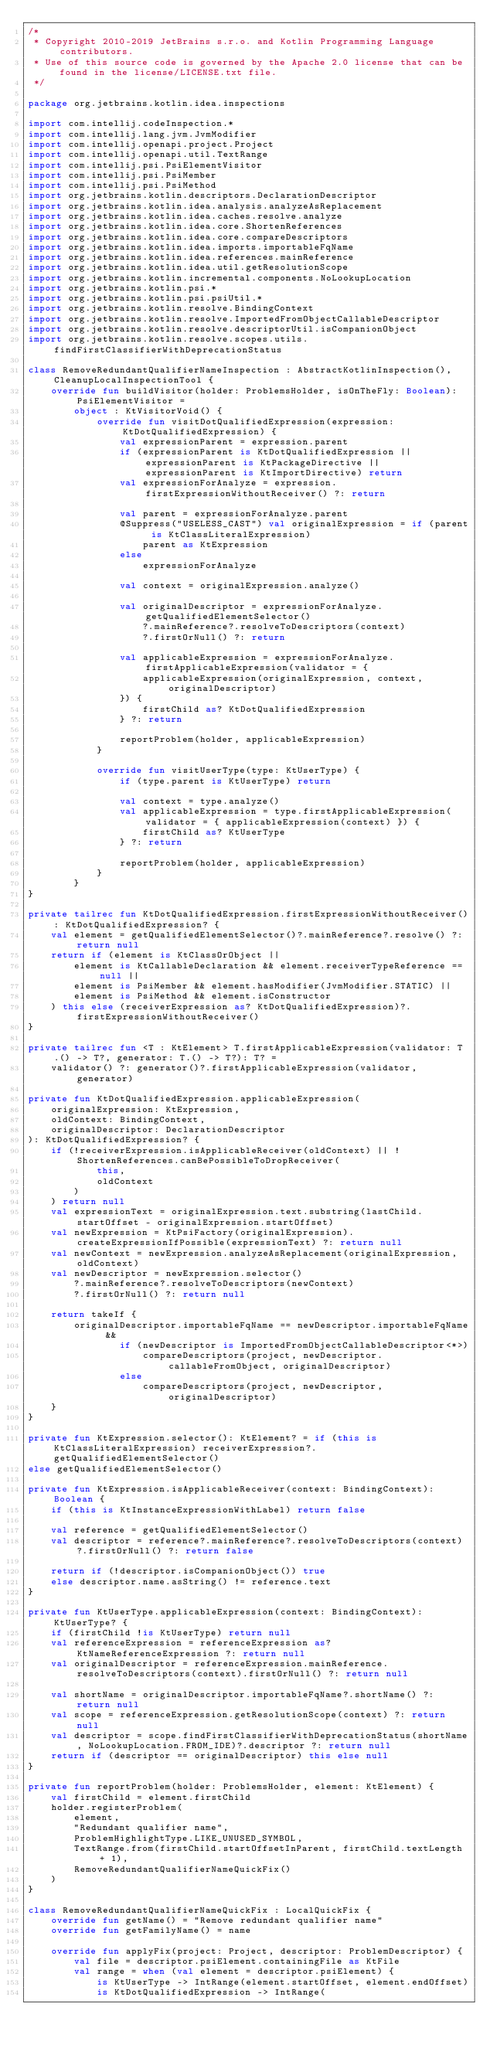Convert code to text. <code><loc_0><loc_0><loc_500><loc_500><_Kotlin_>/*
 * Copyright 2010-2019 JetBrains s.r.o. and Kotlin Programming Language contributors.
 * Use of this source code is governed by the Apache 2.0 license that can be found in the license/LICENSE.txt file.
 */

package org.jetbrains.kotlin.idea.inspections

import com.intellij.codeInspection.*
import com.intellij.lang.jvm.JvmModifier
import com.intellij.openapi.project.Project
import com.intellij.openapi.util.TextRange
import com.intellij.psi.PsiElementVisitor
import com.intellij.psi.PsiMember
import com.intellij.psi.PsiMethod
import org.jetbrains.kotlin.descriptors.DeclarationDescriptor
import org.jetbrains.kotlin.idea.analysis.analyzeAsReplacement
import org.jetbrains.kotlin.idea.caches.resolve.analyze
import org.jetbrains.kotlin.idea.core.ShortenReferences
import org.jetbrains.kotlin.idea.core.compareDescriptors
import org.jetbrains.kotlin.idea.imports.importableFqName
import org.jetbrains.kotlin.idea.references.mainReference
import org.jetbrains.kotlin.idea.util.getResolutionScope
import org.jetbrains.kotlin.incremental.components.NoLookupLocation
import org.jetbrains.kotlin.psi.*
import org.jetbrains.kotlin.psi.psiUtil.*
import org.jetbrains.kotlin.resolve.BindingContext
import org.jetbrains.kotlin.resolve.ImportedFromObjectCallableDescriptor
import org.jetbrains.kotlin.resolve.descriptorUtil.isCompanionObject
import org.jetbrains.kotlin.resolve.scopes.utils.findFirstClassifierWithDeprecationStatus

class RemoveRedundantQualifierNameInspection : AbstractKotlinInspection(), CleanupLocalInspectionTool {
    override fun buildVisitor(holder: ProblemsHolder, isOnTheFly: Boolean): PsiElementVisitor =
        object : KtVisitorVoid() {
            override fun visitDotQualifiedExpression(expression: KtDotQualifiedExpression) {
                val expressionParent = expression.parent
                if (expressionParent is KtDotQualifiedExpression || expressionParent is KtPackageDirective || expressionParent is KtImportDirective) return
                val expressionForAnalyze = expression.firstExpressionWithoutReceiver() ?: return

                val parent = expressionForAnalyze.parent
                @Suppress("USELESS_CAST") val originalExpression = if (parent is KtClassLiteralExpression)
                    parent as KtExpression
                else
                    expressionForAnalyze

                val context = originalExpression.analyze()

                val originalDescriptor = expressionForAnalyze.getQualifiedElementSelector()
                    ?.mainReference?.resolveToDescriptors(context)
                    ?.firstOrNull() ?: return

                val applicableExpression = expressionForAnalyze.firstApplicableExpression(validator = {
                    applicableExpression(originalExpression, context, originalDescriptor)
                }) {
                    firstChild as? KtDotQualifiedExpression
                } ?: return

                reportProblem(holder, applicableExpression)
            }

            override fun visitUserType(type: KtUserType) {
                if (type.parent is KtUserType) return

                val context = type.analyze()
                val applicableExpression = type.firstApplicableExpression(validator = { applicableExpression(context) }) {
                    firstChild as? KtUserType
                } ?: return

                reportProblem(holder, applicableExpression)
            }
        }
}

private tailrec fun KtDotQualifiedExpression.firstExpressionWithoutReceiver(): KtDotQualifiedExpression? {
    val element = getQualifiedElementSelector()?.mainReference?.resolve() ?: return null
    return if (element is KtClassOrObject ||
        element is KtCallableDeclaration && element.receiverTypeReference == null ||
        element is PsiMember && element.hasModifier(JvmModifier.STATIC) ||
        element is PsiMethod && element.isConstructor
    ) this else (receiverExpression as? KtDotQualifiedExpression)?.firstExpressionWithoutReceiver()
}

private tailrec fun <T : KtElement> T.firstApplicableExpression(validator: T.() -> T?, generator: T.() -> T?): T? =
    validator() ?: generator()?.firstApplicableExpression(validator, generator)

private fun KtDotQualifiedExpression.applicableExpression(
    originalExpression: KtExpression,
    oldContext: BindingContext,
    originalDescriptor: DeclarationDescriptor
): KtDotQualifiedExpression? {
    if (!receiverExpression.isApplicableReceiver(oldContext) || !ShortenReferences.canBePossibleToDropReceiver(
            this,
            oldContext
        )
    ) return null
    val expressionText = originalExpression.text.substring(lastChild.startOffset - originalExpression.startOffset)
    val newExpression = KtPsiFactory(originalExpression).createExpressionIfPossible(expressionText) ?: return null
    val newContext = newExpression.analyzeAsReplacement(originalExpression, oldContext)
    val newDescriptor = newExpression.selector()
        ?.mainReference?.resolveToDescriptors(newContext)
        ?.firstOrNull() ?: return null

    return takeIf {
        originalDescriptor.importableFqName == newDescriptor.importableFqName &&
                if (newDescriptor is ImportedFromObjectCallableDescriptor<*>)
                    compareDescriptors(project, newDescriptor.callableFromObject, originalDescriptor)
                else
                    compareDescriptors(project, newDescriptor, originalDescriptor)
    }
}

private fun KtExpression.selector(): KtElement? = if (this is KtClassLiteralExpression) receiverExpression?.getQualifiedElementSelector()
else getQualifiedElementSelector()

private fun KtExpression.isApplicableReceiver(context: BindingContext): Boolean {
    if (this is KtInstanceExpressionWithLabel) return false

    val reference = getQualifiedElementSelector()
    val descriptor = reference?.mainReference?.resolveToDescriptors(context)?.firstOrNull() ?: return false

    return if (!descriptor.isCompanionObject()) true
    else descriptor.name.asString() != reference.text
}

private fun KtUserType.applicableExpression(context: BindingContext): KtUserType? {
    if (firstChild !is KtUserType) return null
    val referenceExpression = referenceExpression as? KtNameReferenceExpression ?: return null
    val originalDescriptor = referenceExpression.mainReference.resolveToDescriptors(context).firstOrNull() ?: return null

    val shortName = originalDescriptor.importableFqName?.shortName() ?: return null
    val scope = referenceExpression.getResolutionScope(context) ?: return null
    val descriptor = scope.findFirstClassifierWithDeprecationStatus(shortName, NoLookupLocation.FROM_IDE)?.descriptor ?: return null
    return if (descriptor == originalDescriptor) this else null
}

private fun reportProblem(holder: ProblemsHolder, element: KtElement) {
    val firstChild = element.firstChild
    holder.registerProblem(
        element,
        "Redundant qualifier name",
        ProblemHighlightType.LIKE_UNUSED_SYMBOL,
        TextRange.from(firstChild.startOffsetInParent, firstChild.textLength + 1),
        RemoveRedundantQualifierNameQuickFix()
    )
}

class RemoveRedundantQualifierNameQuickFix : LocalQuickFix {
    override fun getName() = "Remove redundant qualifier name"
    override fun getFamilyName() = name

    override fun applyFix(project: Project, descriptor: ProblemDescriptor) {
        val file = descriptor.psiElement.containingFile as KtFile
        val range = when (val element = descriptor.psiElement) {
            is KtUserType -> IntRange(element.startOffset, element.endOffset)
            is KtDotQualifiedExpression -> IntRange(</code> 